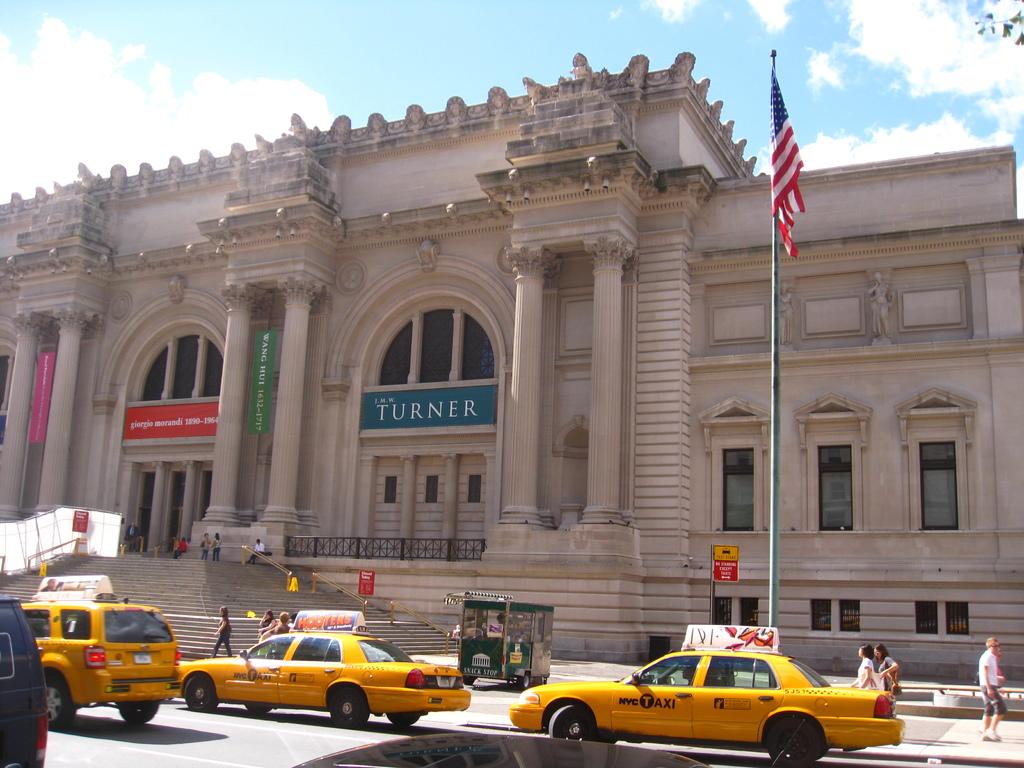What does the blue sign say?
Your answer should be very brief. Turner. What city are these taxis from?
Your response must be concise. Nyc. 